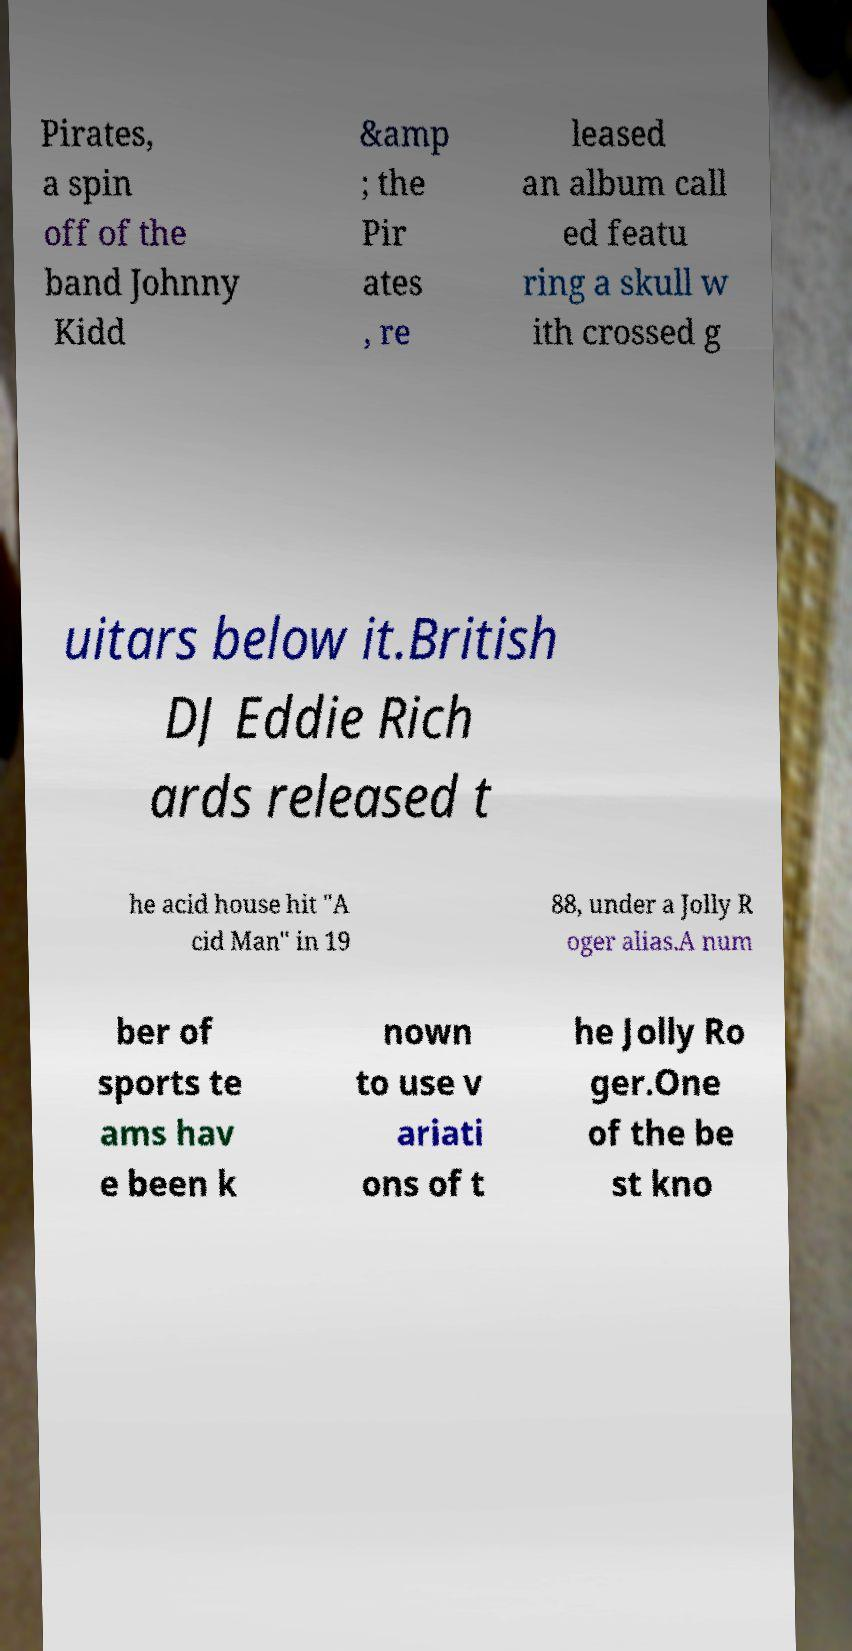What messages or text are displayed in this image? I need them in a readable, typed format. Pirates, a spin off of the band Johnny Kidd &amp ; the Pir ates , re leased an album call ed featu ring a skull w ith crossed g uitars below it.British DJ Eddie Rich ards released t he acid house hit "A cid Man" in 19 88, under a Jolly R oger alias.A num ber of sports te ams hav e been k nown to use v ariati ons of t he Jolly Ro ger.One of the be st kno 